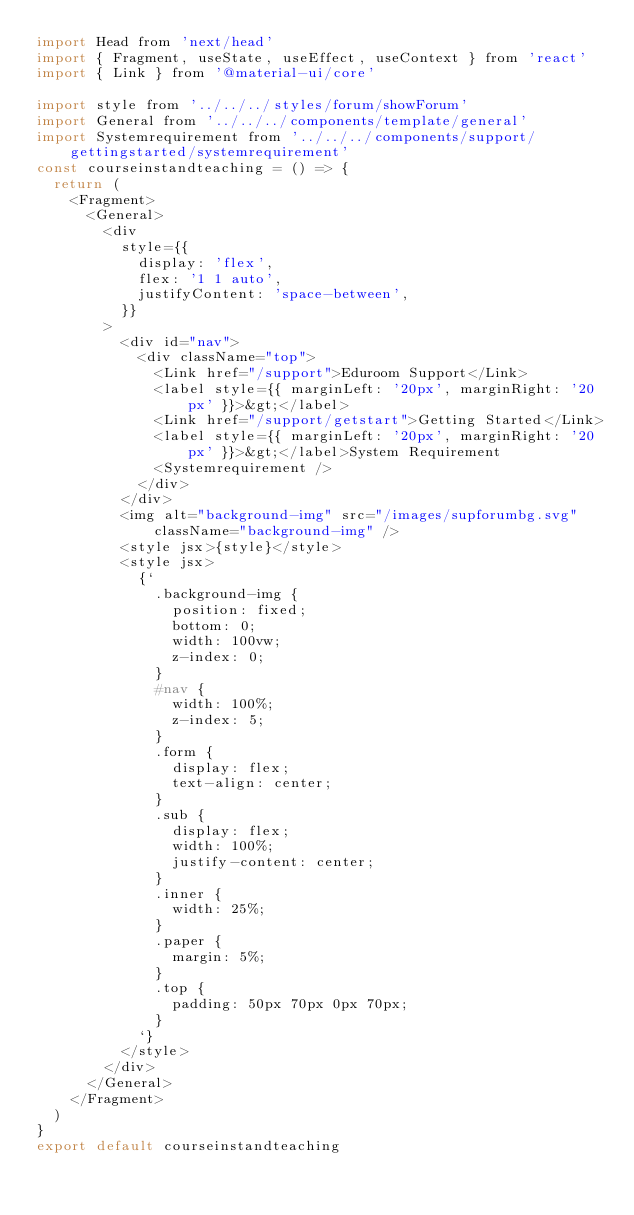<code> <loc_0><loc_0><loc_500><loc_500><_JavaScript_>import Head from 'next/head'
import { Fragment, useState, useEffect, useContext } from 'react'
import { Link } from '@material-ui/core'

import style from '../../../styles/forum/showForum'
import General from '../../../components/template/general'
import Systemrequirement from '../../../components/support/gettingstarted/systemrequirement'
const courseinstandteaching = () => {
	return (
		<Fragment>
			<General>
				<div
					style={{
						display: 'flex',
						flex: '1 1 auto',
						justifyContent: 'space-between',
					}}
				>
					<div id="nav">
						<div className="top">
							<Link href="/support">Eduroom Support</Link>
							<label style={{ marginLeft: '20px', marginRight: '20px' }}>&gt;</label>
							<Link href="/support/getstart">Getting Started</Link>
							<label style={{ marginLeft: '20px', marginRight: '20px' }}>&gt;</label>System Requirement
							<Systemrequirement />
						</div>
					</div>
					<img alt="background-img" src="/images/supforumbg.svg" className="background-img" />
					<style jsx>{style}</style>
					<style jsx>
						{`
							.background-img {
								position: fixed;
								bottom: 0;
								width: 100vw;
								z-index: 0;
							}
							#nav {
								width: 100%;
								z-index: 5;
							}
							.form {
								display: flex;
								text-align: center;
							}
							.sub {
								display: flex;
								width: 100%;
								justify-content: center;
							}
							.inner {
								width: 25%;
							}
							.paper {
								margin: 5%;
							}
							.top {
								padding: 50px 70px 0px 70px;
							}
						`}
					</style>
				</div>
			</General>
		</Fragment>
	)
}
export default courseinstandteaching
</code> 